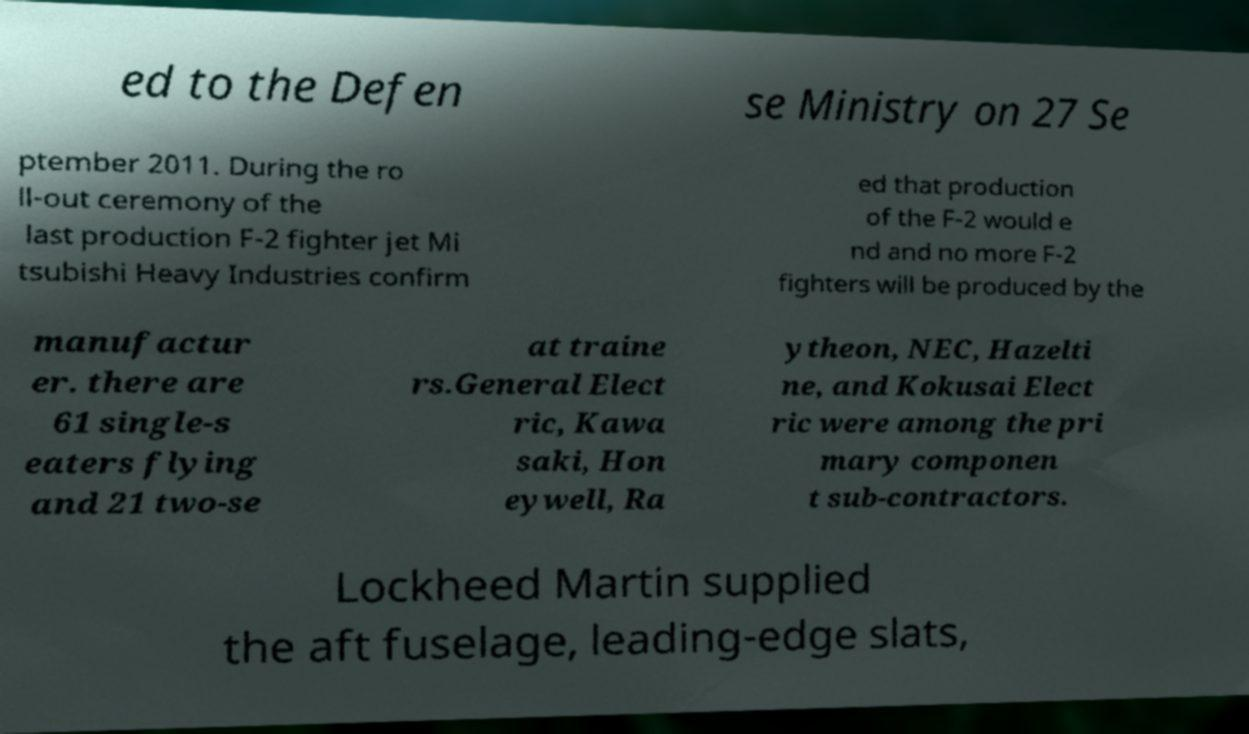I need the written content from this picture converted into text. Can you do that? ed to the Defen se Ministry on 27 Se ptember 2011. During the ro ll-out ceremony of the last production F-2 fighter jet Mi tsubishi Heavy Industries confirm ed that production of the F-2 would e nd and no more F-2 fighters will be produced by the manufactur er. there are 61 single-s eaters flying and 21 two-se at traine rs.General Elect ric, Kawa saki, Hon eywell, Ra ytheon, NEC, Hazelti ne, and Kokusai Elect ric were among the pri mary componen t sub-contractors. Lockheed Martin supplied the aft fuselage, leading-edge slats, 